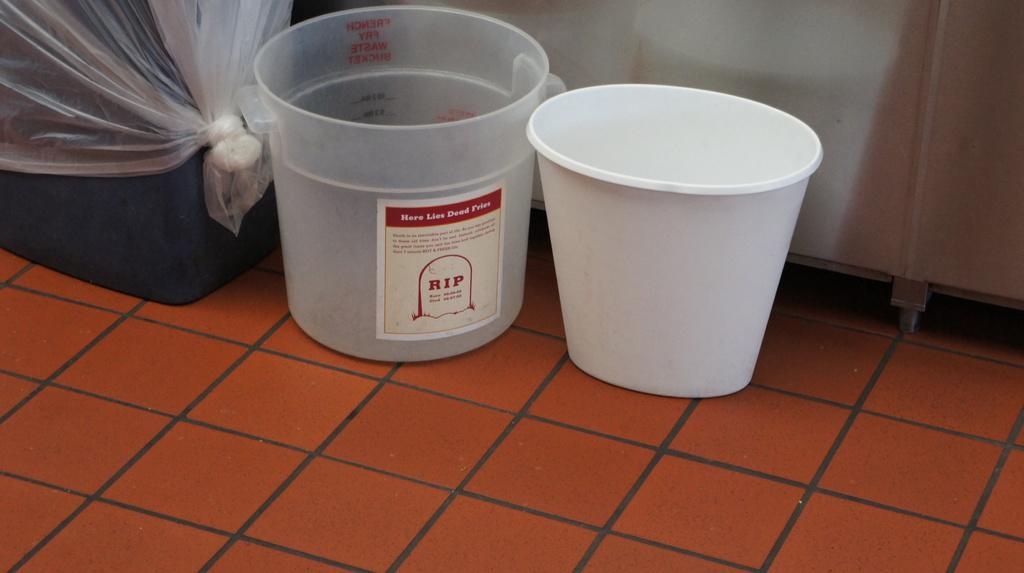<image>
Provide a brief description of the given image. buckets with a label that says 'here lies dead fries' 